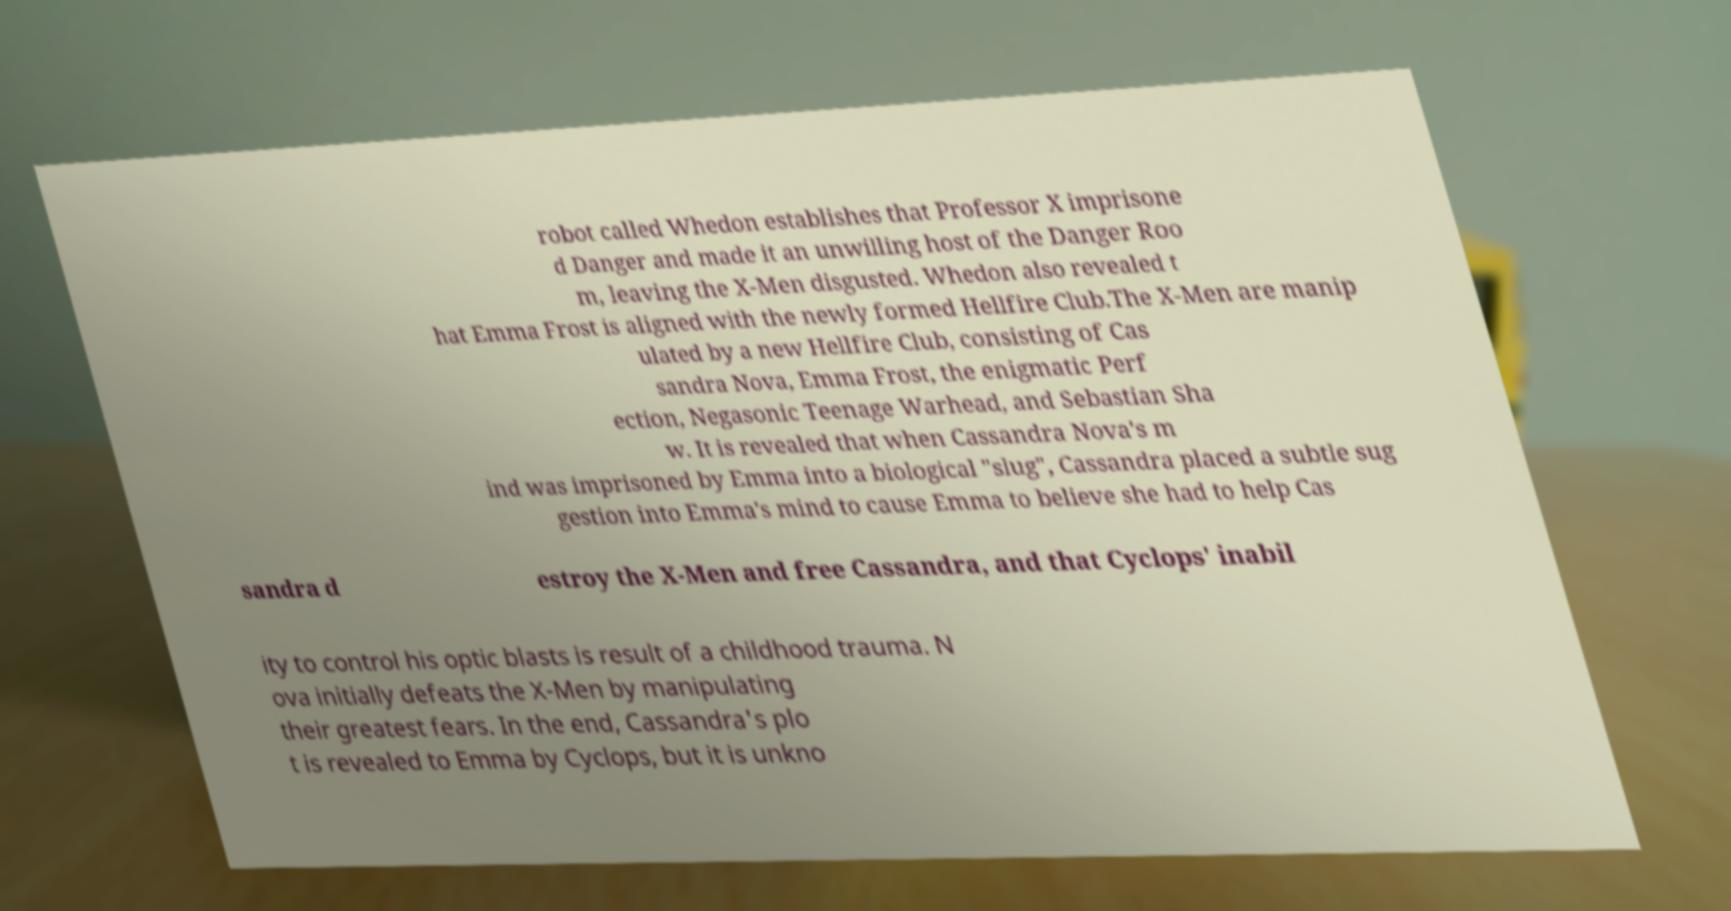There's text embedded in this image that I need extracted. Can you transcribe it verbatim? robot called Whedon establishes that Professor X imprisone d Danger and made it an unwilling host of the Danger Roo m, leaving the X-Men disgusted. Whedon also revealed t hat Emma Frost is aligned with the newly formed Hellfire Club.The X-Men are manip ulated by a new Hellfire Club, consisting of Cas sandra Nova, Emma Frost, the enigmatic Perf ection, Negasonic Teenage Warhead, and Sebastian Sha w. It is revealed that when Cassandra Nova's m ind was imprisoned by Emma into a biological "slug", Cassandra placed a subtle sug gestion into Emma's mind to cause Emma to believe she had to help Cas sandra d estroy the X-Men and free Cassandra, and that Cyclops' inabil ity to control his optic blasts is result of a childhood trauma. N ova initially defeats the X-Men by manipulating their greatest fears. In the end, Cassandra's plo t is revealed to Emma by Cyclops, but it is unkno 